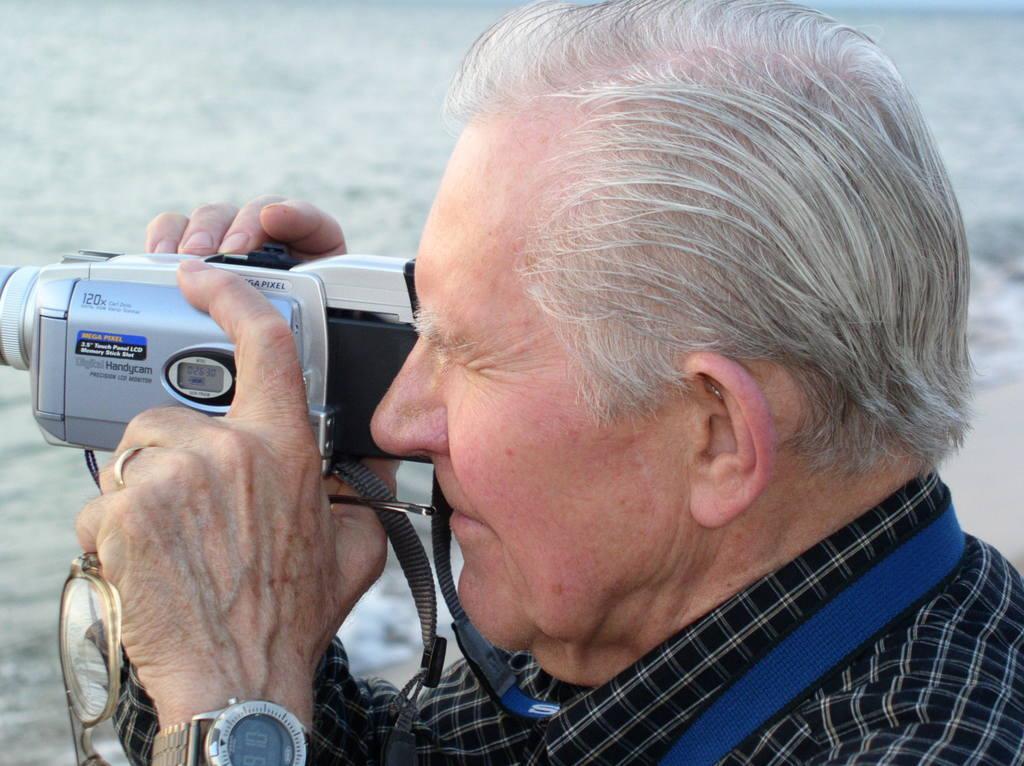Could you give a brief overview of what you see in this image? In this picture there is a man holding a camera in his hand. Camera is grey in color. He is also holding a spectacle in his hand. 